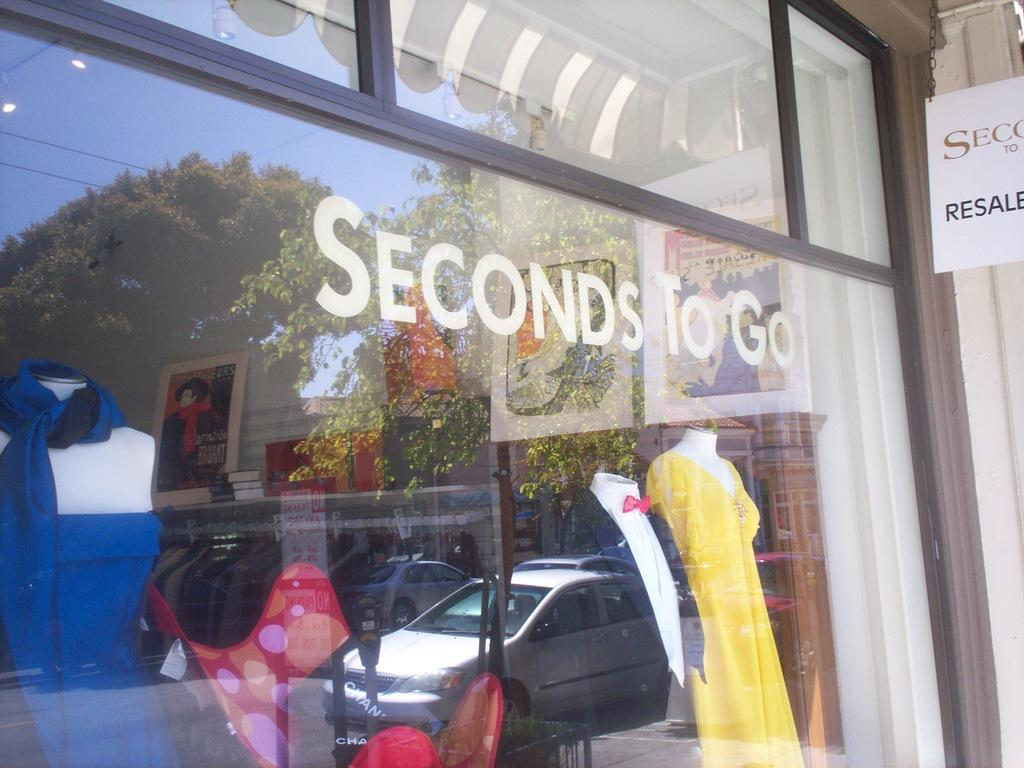What type of establishment is depicted in the image? There is a store front in the image. What can be seen behind the glass of the store front? Mannequins are behind the glass of the store front. What is visible on the glass of the store front? There is a car reflection on the glass of the store front. What information is displayed on the store front? There is some text visible on the store front. What additional feature is present on the store front? There is a board on the store front. What type of music can be heard coming from the store in the image? There is no indication of music or any sound in the image, as it only shows a store front with mannequins, text, and a board. 